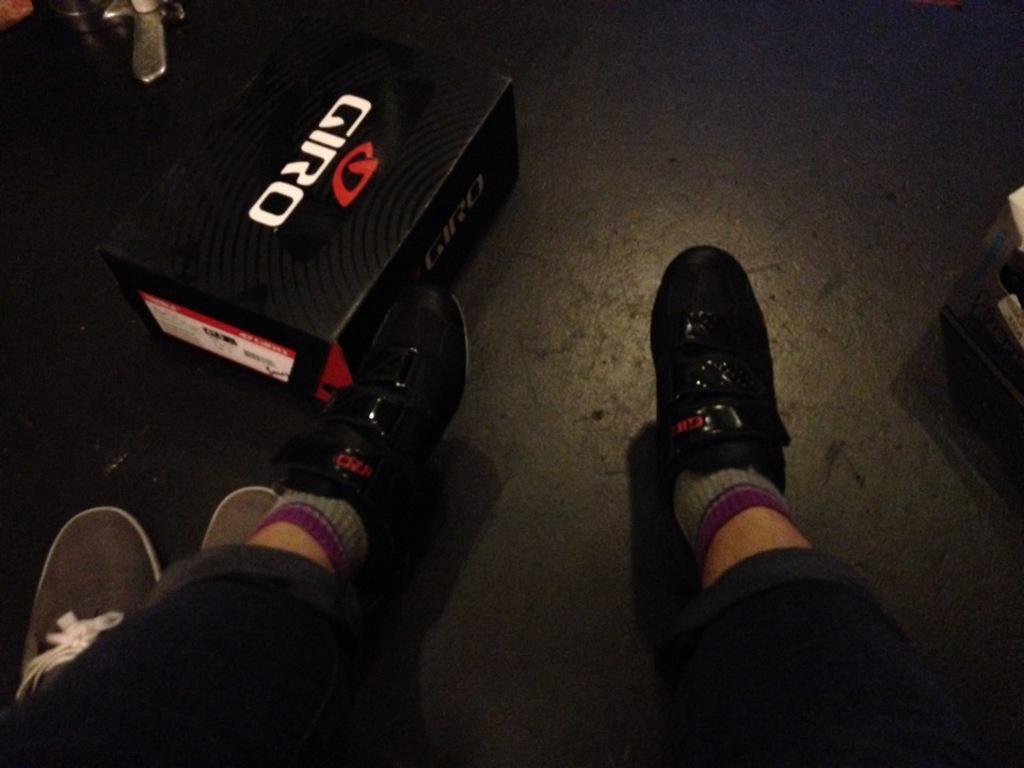Could you give a brief overview of what you see in this image? In this image we can see person's legs and a cardboard carton on the floor. 